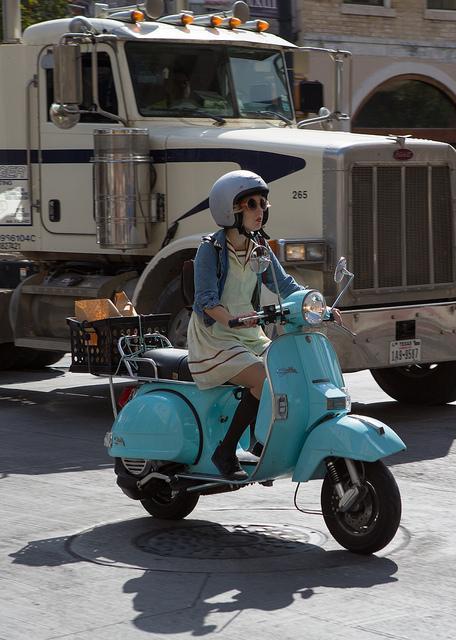How many trucks can be seen?
Give a very brief answer. 1. How many orange slices are on the top piece of breakfast toast?
Give a very brief answer. 0. 